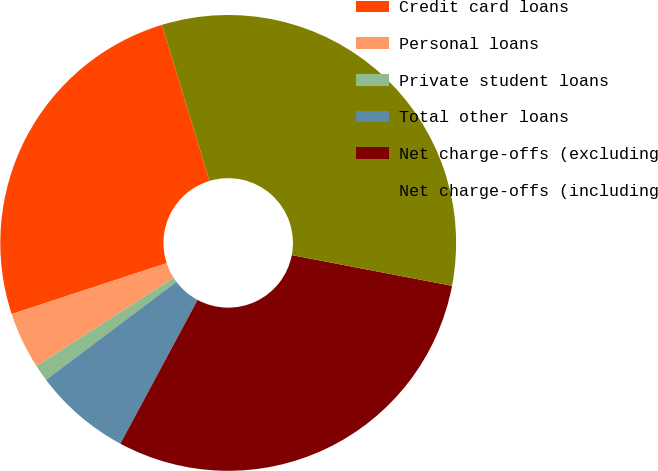Convert chart. <chart><loc_0><loc_0><loc_500><loc_500><pie_chart><fcel>Credit card loans<fcel>Personal loans<fcel>Private student loans<fcel>Total other loans<fcel>Net charge-offs (excluding<fcel>Net charge-offs (including<nl><fcel>25.37%<fcel>4.03%<fcel>1.17%<fcel>6.9%<fcel>29.83%<fcel>32.7%<nl></chart> 